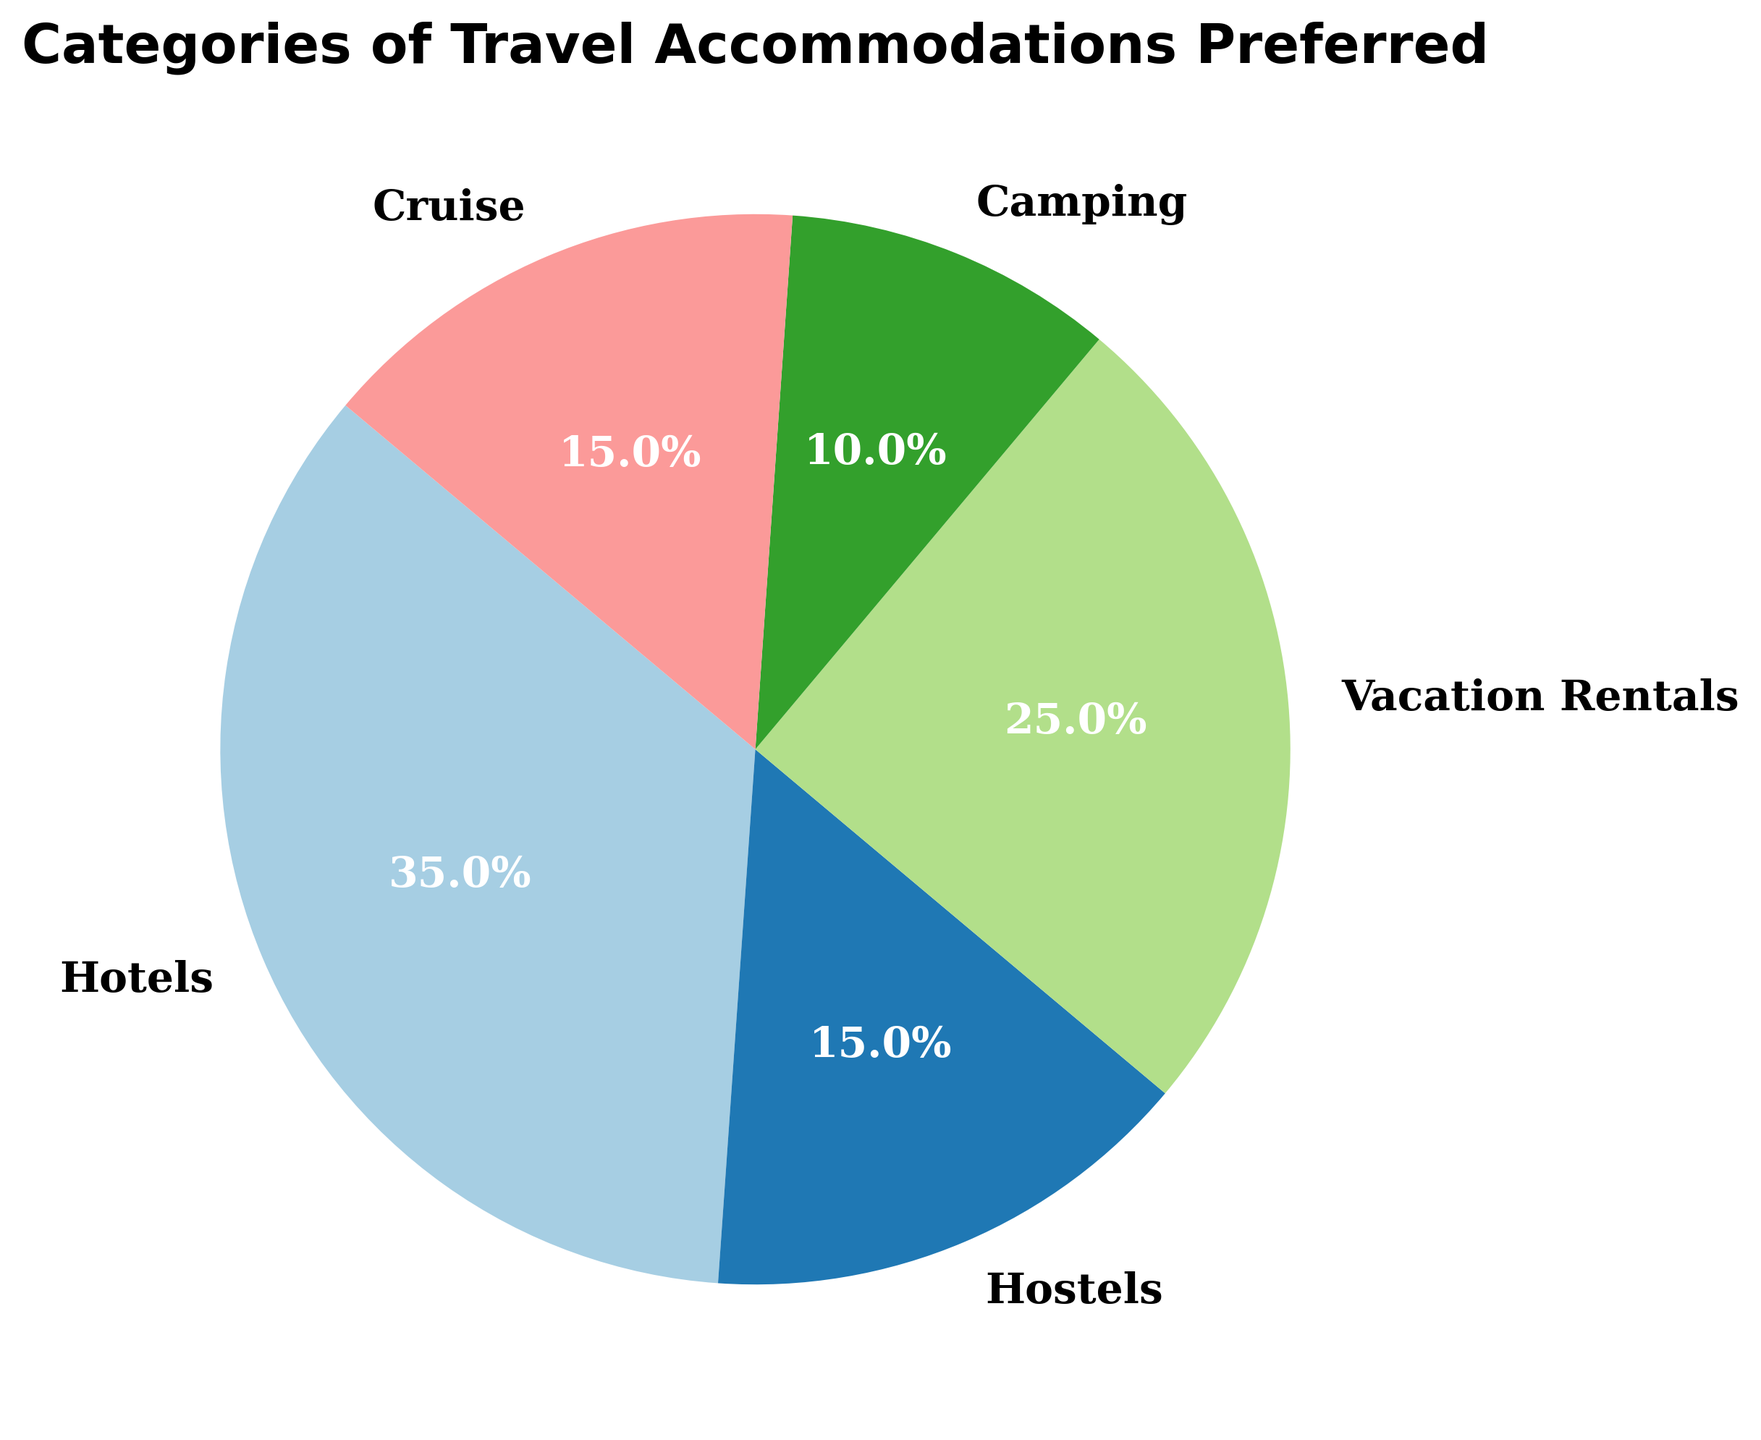Which category of travel accommodation has the highest preference percentage? The highest preference percentage is clearly indicated by the largest segment in the pie chart. In this case, it is the "Hotels" segment.
Answer: Hotels Which two categories of travel accommodations have equal preference percentages? By comparing the sizes and percentage labels of the segments, we see that both "Hostels" and "Cruise" have the same preference percentage of 15%.
Answer: Hostels and Cruise What is the combined preference percentage of Vacation Rentals and Camping? The pie chart shows that Vacation Rentals have a preference of 25% and Camping has 10%. Adding these values together gives 35%.
Answer: 35% How much greater is the preference for Hotels compared to Camping? From the pie chart, Hotels have a 35% preference and Camping has a 10% preference. The difference is 35% - 10% = 25%.
Answer: 25% Which category has the lowest preference percentage, and what percentage is it? The smallest slice in the pie chart represents Camping, which has the lowest preference percentage of 10%.
Answer: Camping with 10% Is the preference percentage for Cruise greater than or less than the preference for Vacation Rentals? Comparing the percentages on the pie chart, Cruise has a preference of 15% while Vacation Rentals have 25%. Therefore, the preference for Cruise is less than Vacation Rentals.
Answer: Less What is the average preference percentage across all categories? Adding up all the percentages: 35% + 15% + 25% + 10% + 15% = 100%. The number of categories is 5. The average is 100% / 5 = 20%.
Answer: 20% Which travel accommodation category is represented with the second largest segment in the pie chart? The second largest segment in the pie chart corresponds to "Vacation Rentals" with a percentage of 25%.
Answer: Vacation Rentals How do the combined percentages of Hotels and Hostels compare to the percentage of Vacation Rentals? The pie chart shows Hotels at 35% and Hostels at 15%. Combined, they have 35% + 15% = 50%. Compared to Vacation Rentals, which is 25%, the combined percentage of Hotels and Hostels is higher.
Answer: Higher If you combine the preferences for all accommodations other than Hotels, what is the total percentage? The preferences for all other categories are: Hostels 15%, Vacation Rentals 25%, Camping 10%, and Cruise 15%. Combined, they add up to 15% + 25% + 10% + 15% = 65%.
Answer: 65% 